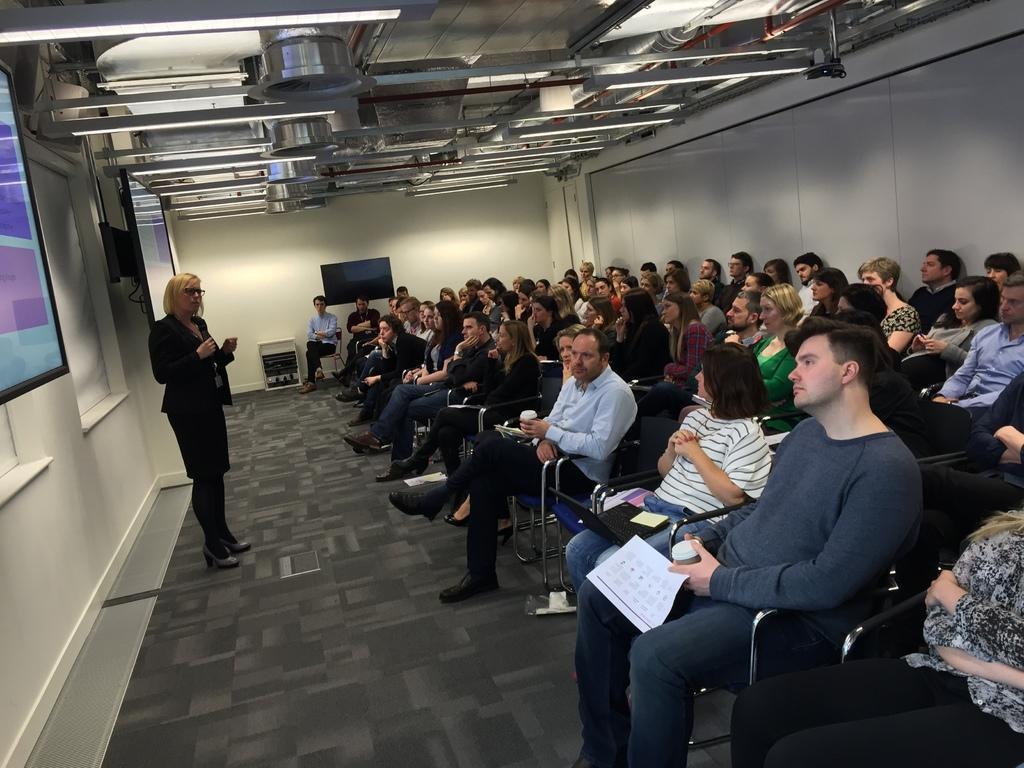Describe this image in one or two sentences. In this image, we can see people sitting on the chairs and some are holding objects and there is a lady standing and wearing glasses and holding an object. In the background, we can see screens on the wall and there are lights. 